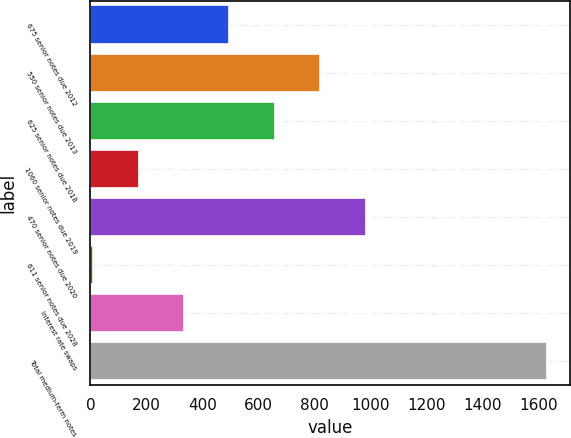Convert chart. <chart><loc_0><loc_0><loc_500><loc_500><bar_chart><fcel>675 senior notes due 2012<fcel>550 senior notes due 2013<fcel>625 senior notes due 2018<fcel>1060 senior notes due 2019<fcel>470 senior notes due 2020<fcel>611 senior notes due 2028<fcel>Interest rate swaps<fcel>Total medium-term notes<nl><fcel>496.69<fcel>821.15<fcel>658.92<fcel>172.23<fcel>983.38<fcel>10<fcel>334.46<fcel>1632.3<nl></chart> 